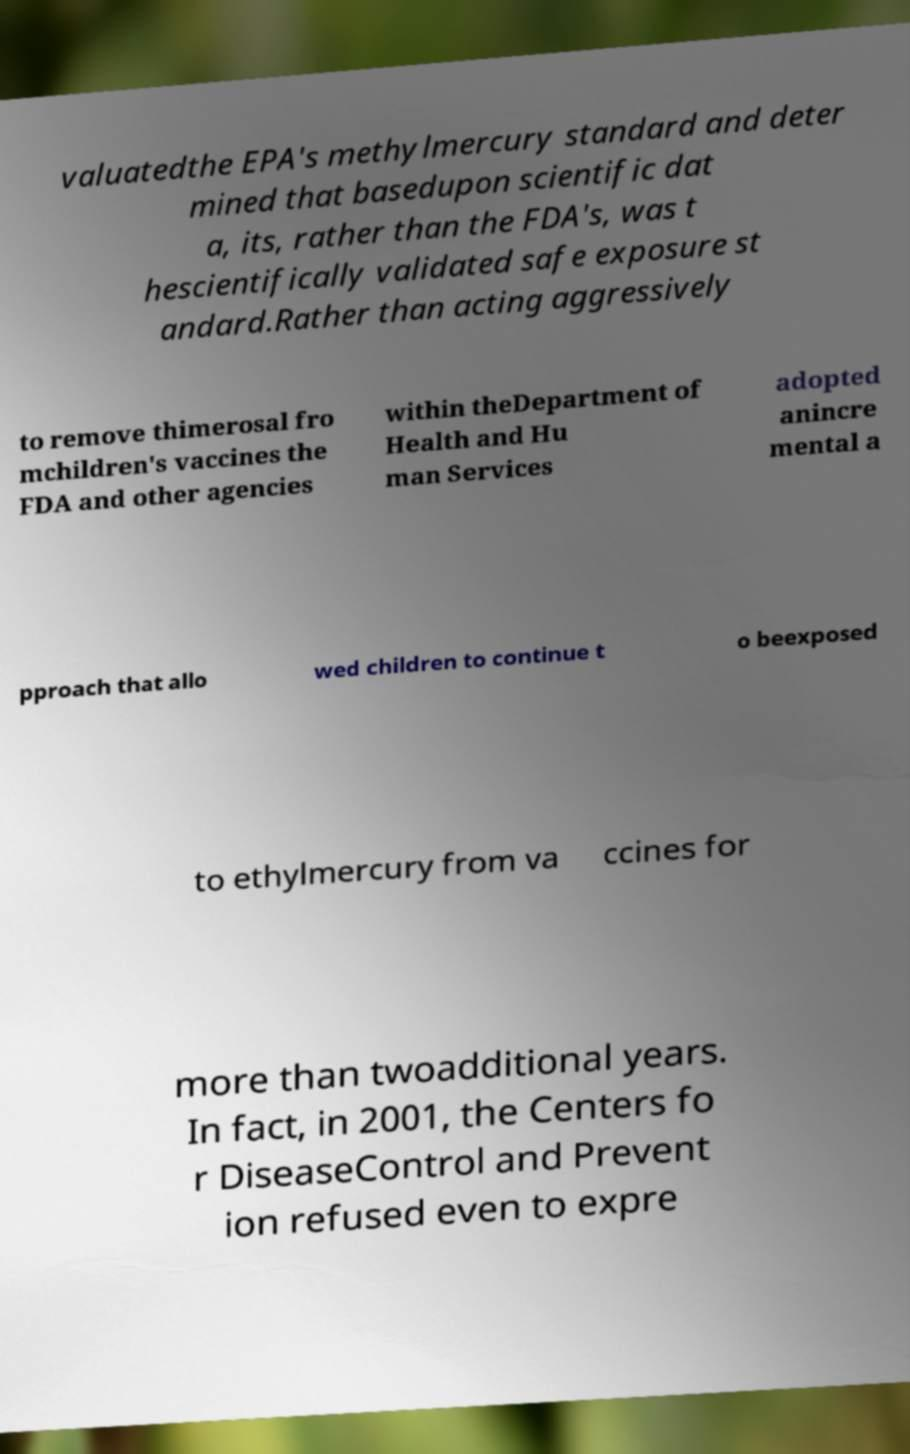Could you assist in decoding the text presented in this image and type it out clearly? valuatedthe EPA's methylmercury standard and deter mined that basedupon scientific dat a, its, rather than the FDA's, was t hescientifically validated safe exposure st andard.Rather than acting aggressively to remove thimerosal fro mchildren's vaccines the FDA and other agencies within theDepartment of Health and Hu man Services adopted anincre mental a pproach that allo wed children to continue t o beexposed to ethylmercury from va ccines for more than twoadditional years. In fact, in 2001, the Centers fo r DiseaseControl and Prevent ion refused even to expre 